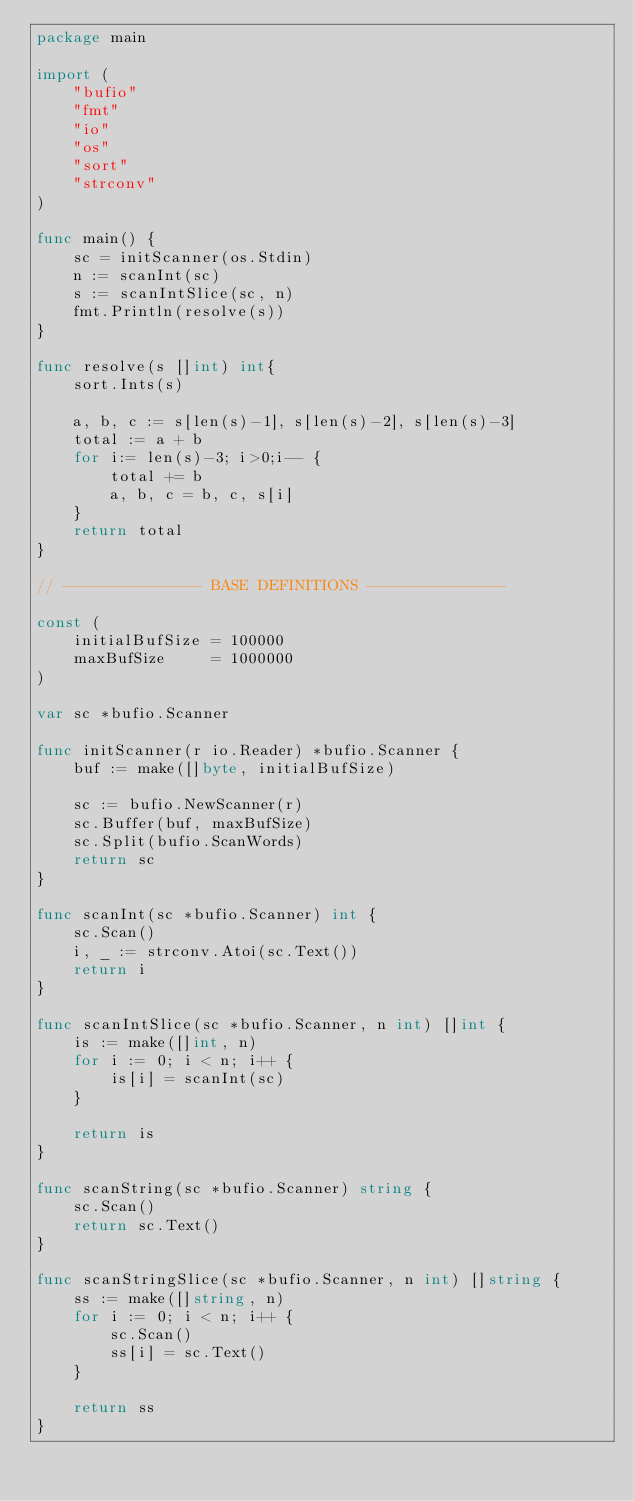<code> <loc_0><loc_0><loc_500><loc_500><_Go_>package main

import (
	"bufio"
	"fmt"
	"io"
	"os"
	"sort"
	"strconv"
)

func main() {
	sc = initScanner(os.Stdin)
	n := scanInt(sc)
	s := scanIntSlice(sc, n)
	fmt.Println(resolve(s))
}

func resolve(s []int) int{
	sort.Ints(s)

	a, b, c := s[len(s)-1], s[len(s)-2], s[len(s)-3]
	total := a + b
	for i:= len(s)-3; i>0;i-- {
		total += b
		a, b, c = b, c, s[i]
	}
	return total
}

// --------------- BASE DEFINITIONS ---------------

const (
	initialBufSize = 100000
	maxBufSize     = 1000000
)

var sc *bufio.Scanner

func initScanner(r io.Reader) *bufio.Scanner {
	buf := make([]byte, initialBufSize)

	sc := bufio.NewScanner(r)
	sc.Buffer(buf, maxBufSize)
	sc.Split(bufio.ScanWords)
	return sc
}

func scanInt(sc *bufio.Scanner) int {
	sc.Scan()
	i, _ := strconv.Atoi(sc.Text())
	return i
}

func scanIntSlice(sc *bufio.Scanner, n int) []int {
	is := make([]int, n)
	for i := 0; i < n; i++ {
		is[i] = scanInt(sc)
	}

	return is
}

func scanString(sc *bufio.Scanner) string {
	sc.Scan()
	return sc.Text()
}

func scanStringSlice(sc *bufio.Scanner, n int) []string {
	ss := make([]string, n)
	for i := 0; i < n; i++ {
		sc.Scan()
		ss[i] = sc.Text()
	}

	return ss
}
</code> 